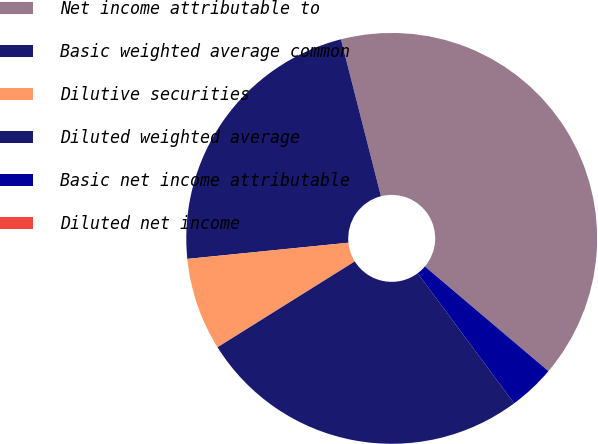Convert chart. <chart><loc_0><loc_0><loc_500><loc_500><pie_chart><fcel>Net income attributable to<fcel>Basic weighted average common<fcel>Dilutive securities<fcel>Diluted weighted average<fcel>Basic net income attributable<fcel>Diluted net income<nl><fcel>40.16%<fcel>22.62%<fcel>7.3%<fcel>26.27%<fcel>3.65%<fcel>0.0%<nl></chart> 